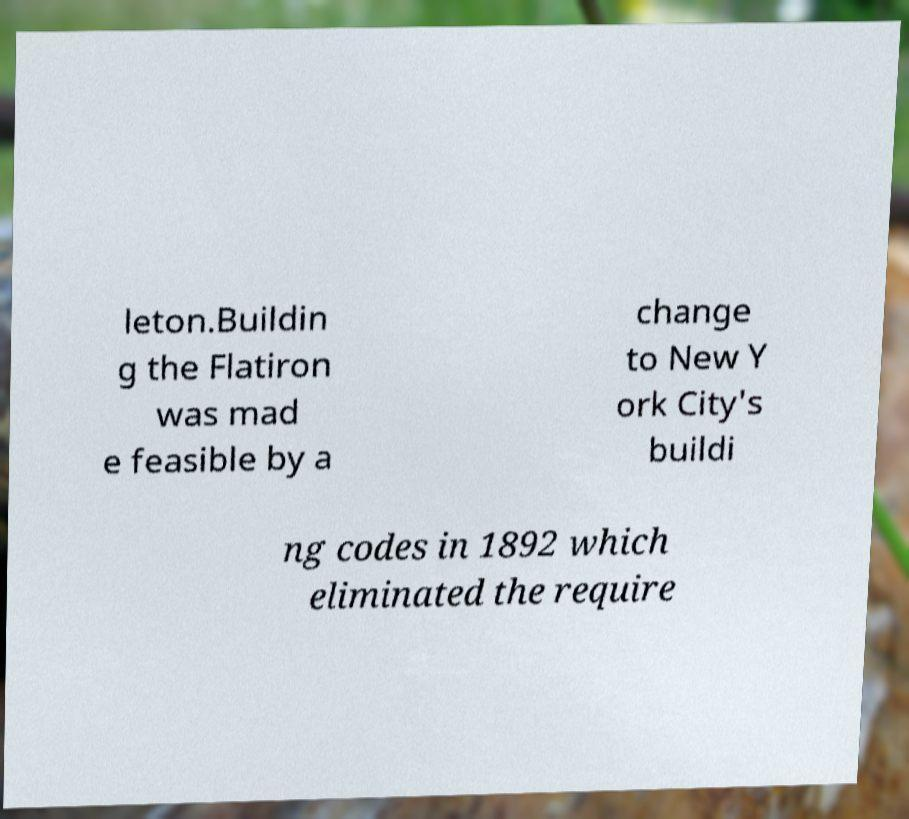Could you assist in decoding the text presented in this image and type it out clearly? leton.Buildin g the Flatiron was mad e feasible by a change to New Y ork City's buildi ng codes in 1892 which eliminated the require 